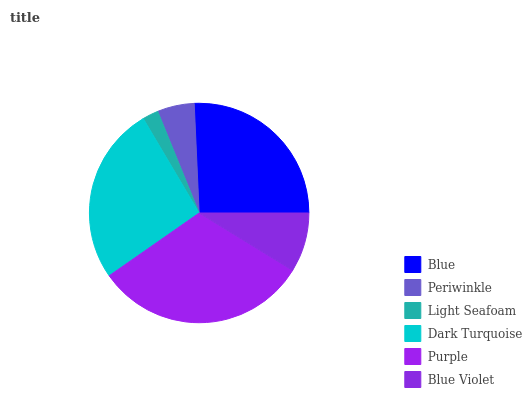Is Light Seafoam the minimum?
Answer yes or no. Yes. Is Purple the maximum?
Answer yes or no. Yes. Is Periwinkle the minimum?
Answer yes or no. No. Is Periwinkle the maximum?
Answer yes or no. No. Is Blue greater than Periwinkle?
Answer yes or no. Yes. Is Periwinkle less than Blue?
Answer yes or no. Yes. Is Periwinkle greater than Blue?
Answer yes or no. No. Is Blue less than Periwinkle?
Answer yes or no. No. Is Blue the high median?
Answer yes or no. Yes. Is Blue Violet the low median?
Answer yes or no. Yes. Is Purple the high median?
Answer yes or no. No. Is Dark Turquoise the low median?
Answer yes or no. No. 